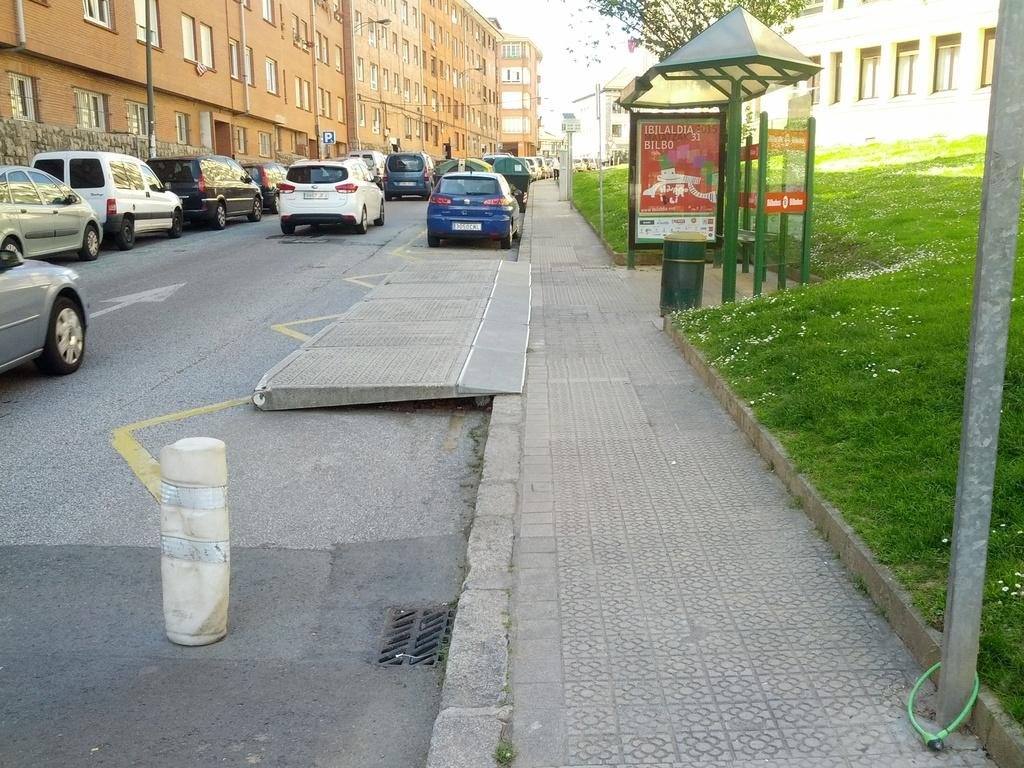What can be seen on the road in the image? There are cars on the road in the image. What is visible in the background of the image? There are buildings, trees, a board, and the sky visible in the background of the image. What type of soup is being served at the protest in the image? There is no protest or soup present in the image. How many balloons are tied to the board in the image? There are no balloons present in the image. 